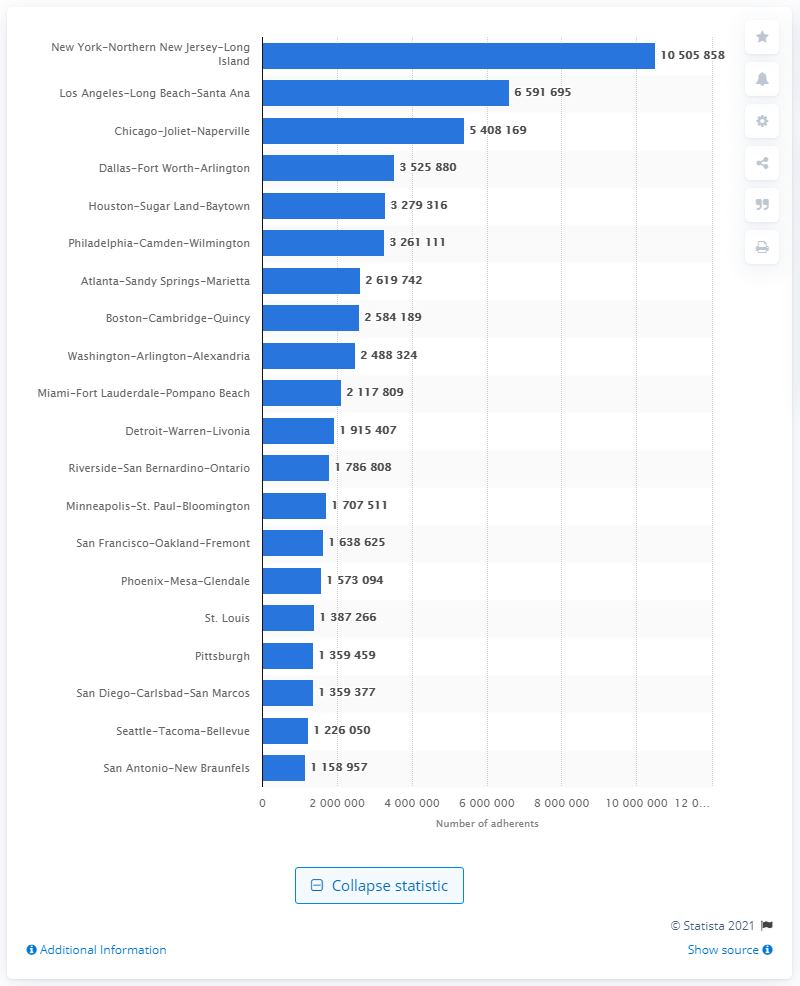Specify some key components in this picture. As of 2010, approximately 10.5 million people affiliated with a religious group lived in the New York-Northern New Jersey-Long Island area. In 2010, it is estimated that approximately 10,505,858 individuals adhered to a religious faith in the New York-Northern New Jersey-Long Island region. 